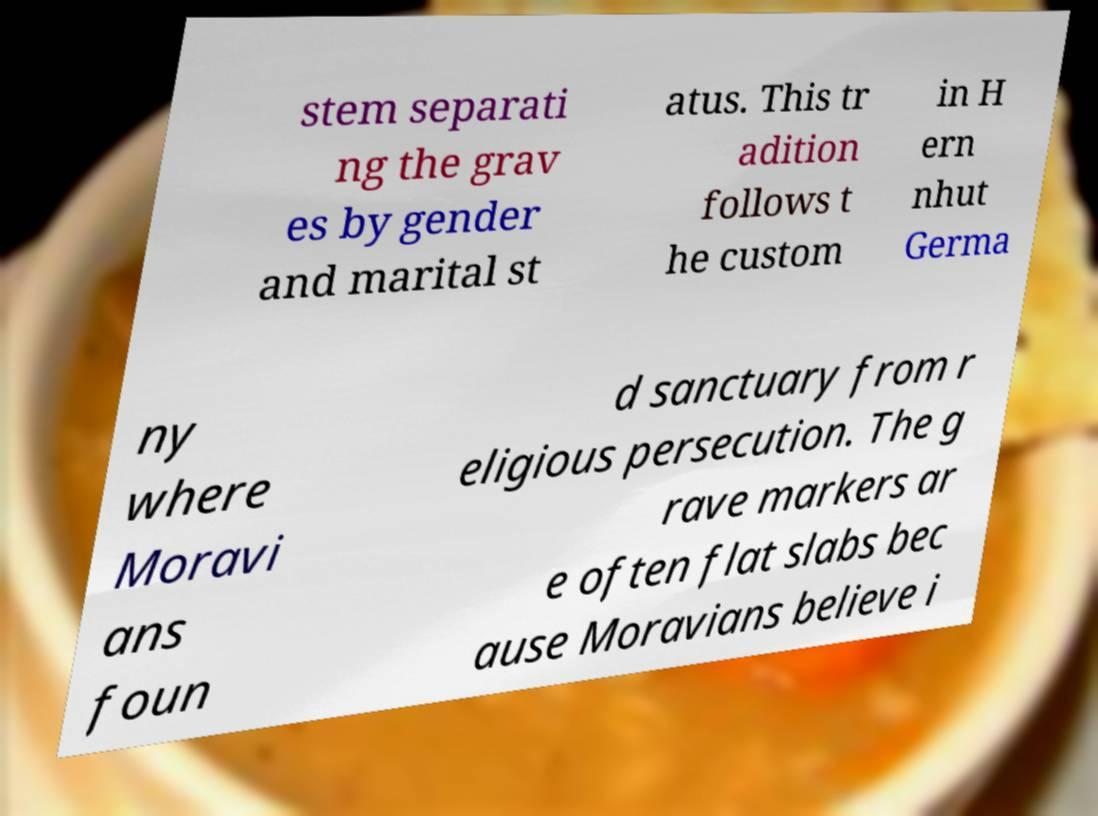Please identify and transcribe the text found in this image. stem separati ng the grav es by gender and marital st atus. This tr adition follows t he custom in H ern nhut Germa ny where Moravi ans foun d sanctuary from r eligious persecution. The g rave markers ar e often flat slabs bec ause Moravians believe i 